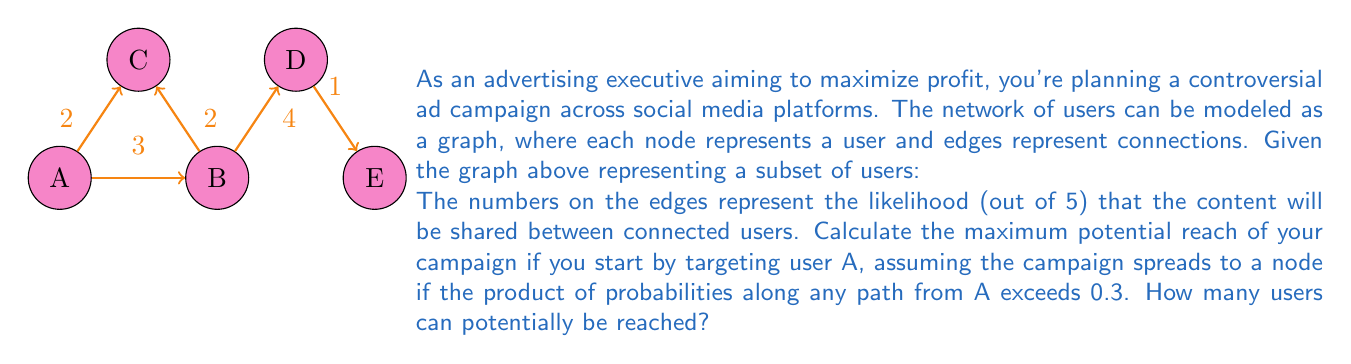What is the answer to this math problem? Let's approach this step-by-step:

1) First, we need to convert the likelihoods on the edges to probabilities:
   $P(A \to B) = \frac{3}{5} = 0.6$
   $P(A \to C) = P(B \to C) = \frac{2}{5} = 0.4$
   $P(B \to D) = \frac{4}{5} = 0.8$
   $P(D \to E) = \frac{1}{5} = 0.2$

2) Now, let's calculate the probabilities of reaching each node from A:

   - A: Always reached (starting point)
   - B: Direct path A → B
     $P(A \to B) = 0.6 > 0.3$, so B is reached
   - C: Two paths
     Path 1: A → C, $P = 0.4 > 0.3$
     Path 2: A → B → C, $P = 0.6 \times 0.4 = 0.24 < 0.3$
     C is reached via Path 1
   - D: Path A → B → D
     $P = 0.6 \times 0.8 = 0.48 > 0.3$, so D is reached
   - E: Path A → B → D → E
     $P = 0.6 \times 0.8 \times 0.2 = 0.096 < 0.3$, so E is not reached

3) Counting the reached nodes: A, B, C, and D are reached.

Therefore, 4 users can potentially be reached by the campaign.
Answer: 4 users 